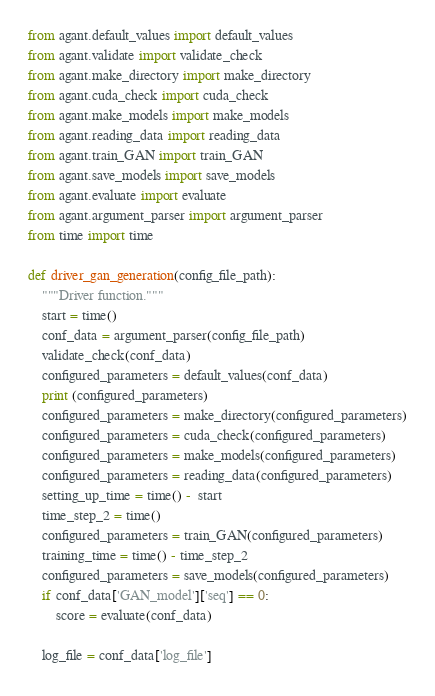Convert code to text. <code><loc_0><loc_0><loc_500><loc_500><_Python_>from agant.default_values import default_values
from agant.validate import validate_check
from agant.make_directory import make_directory
from agant.cuda_check import cuda_check
from agant.make_models import make_models
from agant.reading_data import reading_data
from agant.train_GAN import train_GAN
from agant.save_models import save_models
from agant.evaluate import evaluate
from agant.argument_parser import argument_parser
from time import time

def driver_gan_generation(config_file_path):
	"""Driver function."""
	start = time()
	conf_data = argument_parser(config_file_path)
	validate_check(conf_data)
	configured_parameters = default_values(conf_data)
	print (configured_parameters)
	configured_parameters = make_directory(configured_parameters)
	configured_parameters = cuda_check(configured_parameters)
	configured_parameters = make_models(configured_parameters)
	configured_parameters = reading_data(configured_parameters)
	setting_up_time = time() -  start
	time_step_2 = time()
	configured_parameters = train_GAN(configured_parameters)
	training_time = time() - time_step_2
	configured_parameters = save_models(configured_parameters)
	if conf_data['GAN_model']['seq'] == 0:
		score = evaluate(conf_data)

	log_file = conf_data['log_file']</code> 